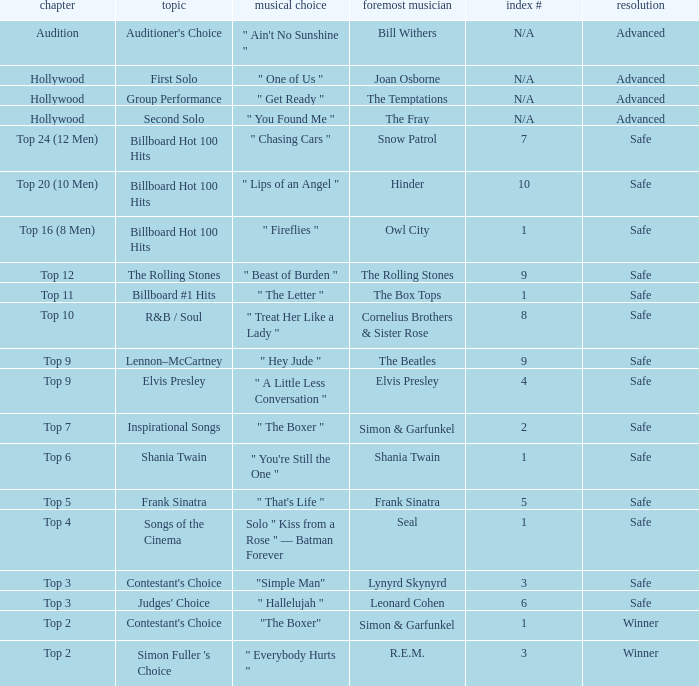In episode Top 16 (8 Men), what are the themes? Billboard Hot 100 Hits. 